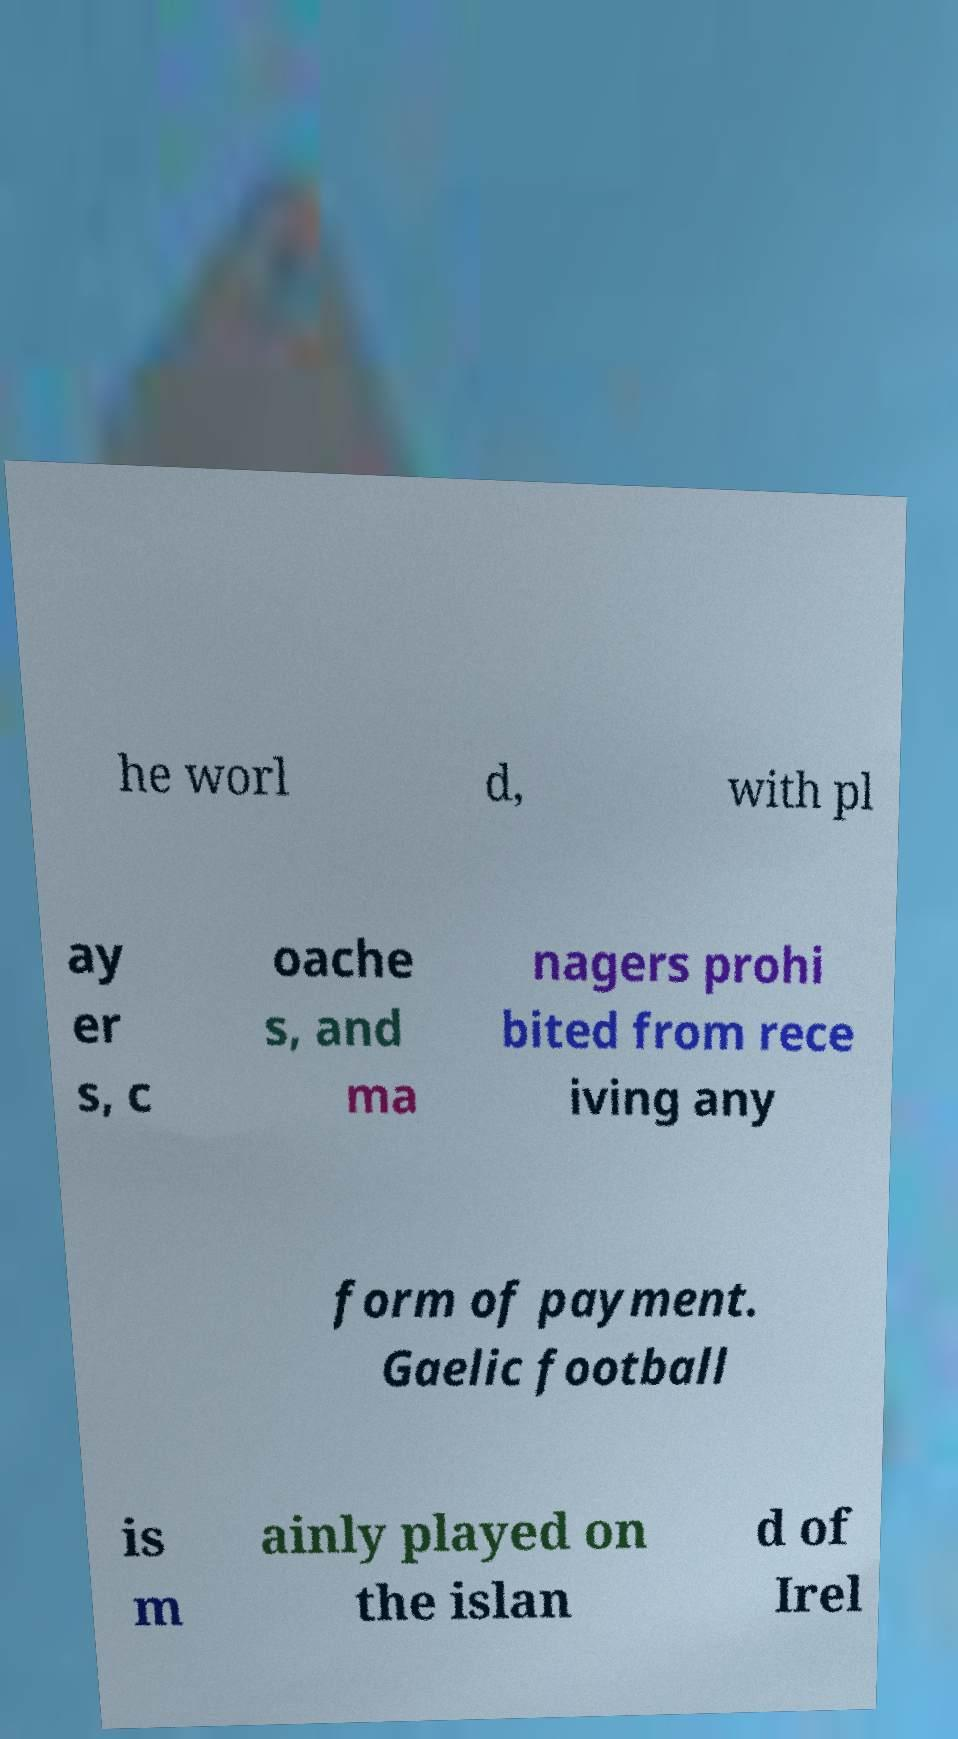Please read and relay the text visible in this image. What does it say? he worl d, with pl ay er s, c oache s, and ma nagers prohi bited from rece iving any form of payment. Gaelic football is m ainly played on the islan d of Irel 